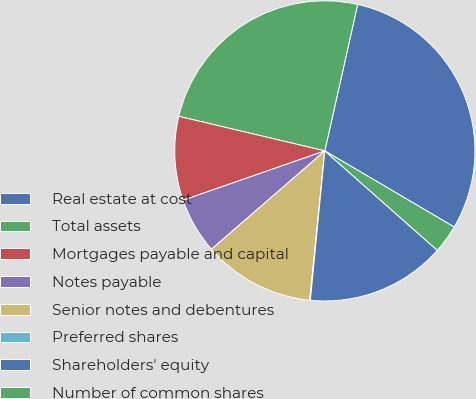Convert chart. <chart><loc_0><loc_0><loc_500><loc_500><pie_chart><fcel>Real estate at cost<fcel>Total assets<fcel>Mortgages payable and capital<fcel>Notes payable<fcel>Senior notes and debentures<fcel>Preferred shares<fcel>Shareholders' equity<fcel>Number of common shares<nl><fcel>29.95%<fcel>24.81%<fcel>9.03%<fcel>6.04%<fcel>12.02%<fcel>0.07%<fcel>15.01%<fcel>3.06%<nl></chart> 